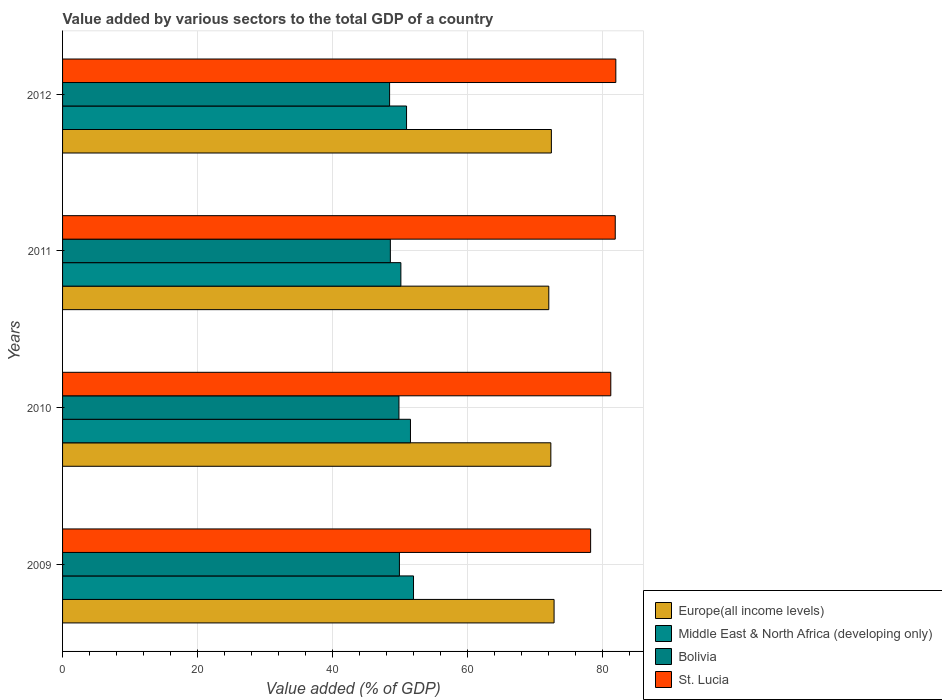How many different coloured bars are there?
Keep it short and to the point. 4. How many groups of bars are there?
Provide a succinct answer. 4. Are the number of bars per tick equal to the number of legend labels?
Your response must be concise. Yes. What is the label of the 4th group of bars from the top?
Your answer should be compact. 2009. What is the value added by various sectors to the total GDP in Europe(all income levels) in 2011?
Provide a succinct answer. 72.07. Across all years, what is the maximum value added by various sectors to the total GDP in Bolivia?
Ensure brevity in your answer.  49.93. Across all years, what is the minimum value added by various sectors to the total GDP in Europe(all income levels)?
Offer a very short reply. 72.07. In which year was the value added by various sectors to the total GDP in Middle East & North Africa (developing only) minimum?
Your answer should be compact. 2011. What is the total value added by various sectors to the total GDP in Middle East & North Africa (developing only) in the graph?
Ensure brevity in your answer.  204.71. What is the difference between the value added by various sectors to the total GDP in Europe(all income levels) in 2010 and that in 2011?
Offer a terse response. 0.3. What is the difference between the value added by various sectors to the total GDP in Middle East & North Africa (developing only) in 2011 and the value added by various sectors to the total GDP in Bolivia in 2012?
Your answer should be very brief. 1.67. What is the average value added by various sectors to the total GDP in Bolivia per year?
Make the answer very short. 49.21. In the year 2010, what is the difference between the value added by various sectors to the total GDP in Bolivia and value added by various sectors to the total GDP in St. Lucia?
Ensure brevity in your answer.  -31.4. What is the ratio of the value added by various sectors to the total GDP in St. Lucia in 2009 to that in 2010?
Provide a succinct answer. 0.96. Is the value added by various sectors to the total GDP in Bolivia in 2011 less than that in 2012?
Your answer should be compact. No. Is the difference between the value added by various sectors to the total GDP in Bolivia in 2009 and 2011 greater than the difference between the value added by various sectors to the total GDP in St. Lucia in 2009 and 2011?
Provide a succinct answer. Yes. What is the difference between the highest and the second highest value added by various sectors to the total GDP in Europe(all income levels)?
Ensure brevity in your answer.  0.4. What is the difference between the highest and the lowest value added by various sectors to the total GDP in Middle East & North Africa (developing only)?
Offer a terse response. 1.88. Is the sum of the value added by various sectors to the total GDP in Europe(all income levels) in 2009 and 2012 greater than the maximum value added by various sectors to the total GDP in Bolivia across all years?
Make the answer very short. Yes. What does the 1st bar from the top in 2012 represents?
Give a very brief answer. St. Lucia. What does the 4th bar from the bottom in 2009 represents?
Your answer should be very brief. St. Lucia. Are all the bars in the graph horizontal?
Ensure brevity in your answer.  Yes. What is the difference between two consecutive major ticks on the X-axis?
Ensure brevity in your answer.  20. Are the values on the major ticks of X-axis written in scientific E-notation?
Provide a short and direct response. No. Does the graph contain grids?
Your answer should be compact. Yes. What is the title of the graph?
Ensure brevity in your answer.  Value added by various sectors to the total GDP of a country. What is the label or title of the X-axis?
Make the answer very short. Value added (% of GDP). What is the label or title of the Y-axis?
Offer a terse response. Years. What is the Value added (% of GDP) in Europe(all income levels) in 2009?
Make the answer very short. 72.85. What is the Value added (% of GDP) in Middle East & North Africa (developing only) in 2009?
Provide a succinct answer. 52.02. What is the Value added (% of GDP) in Bolivia in 2009?
Your answer should be very brief. 49.93. What is the Value added (% of GDP) of St. Lucia in 2009?
Provide a succinct answer. 78.27. What is the Value added (% of GDP) of Europe(all income levels) in 2010?
Provide a short and direct response. 72.37. What is the Value added (% of GDP) of Middle East & North Africa (developing only) in 2010?
Offer a very short reply. 51.56. What is the Value added (% of GDP) of Bolivia in 2010?
Offer a very short reply. 49.86. What is the Value added (% of GDP) in St. Lucia in 2010?
Make the answer very short. 81.26. What is the Value added (% of GDP) of Europe(all income levels) in 2011?
Your response must be concise. 72.07. What is the Value added (% of GDP) of Middle East & North Africa (developing only) in 2011?
Keep it short and to the point. 50.14. What is the Value added (% of GDP) in Bolivia in 2011?
Make the answer very short. 48.58. What is the Value added (% of GDP) of St. Lucia in 2011?
Provide a short and direct response. 81.91. What is the Value added (% of GDP) of Europe(all income levels) in 2012?
Your response must be concise. 72.45. What is the Value added (% of GDP) of Middle East & North Africa (developing only) in 2012?
Offer a terse response. 50.98. What is the Value added (% of GDP) in Bolivia in 2012?
Your answer should be very brief. 48.47. What is the Value added (% of GDP) in St. Lucia in 2012?
Provide a short and direct response. 82. Across all years, what is the maximum Value added (% of GDP) in Europe(all income levels)?
Make the answer very short. 72.85. Across all years, what is the maximum Value added (% of GDP) in Middle East & North Africa (developing only)?
Give a very brief answer. 52.02. Across all years, what is the maximum Value added (% of GDP) of Bolivia?
Offer a very short reply. 49.93. Across all years, what is the maximum Value added (% of GDP) of St. Lucia?
Keep it short and to the point. 82. Across all years, what is the minimum Value added (% of GDP) of Europe(all income levels)?
Make the answer very short. 72.07. Across all years, what is the minimum Value added (% of GDP) in Middle East & North Africa (developing only)?
Your response must be concise. 50.14. Across all years, what is the minimum Value added (% of GDP) of Bolivia?
Your response must be concise. 48.47. Across all years, what is the minimum Value added (% of GDP) in St. Lucia?
Ensure brevity in your answer.  78.27. What is the total Value added (% of GDP) in Europe(all income levels) in the graph?
Offer a very short reply. 289.73. What is the total Value added (% of GDP) in Middle East & North Africa (developing only) in the graph?
Give a very brief answer. 204.71. What is the total Value added (% of GDP) of Bolivia in the graph?
Keep it short and to the point. 196.84. What is the total Value added (% of GDP) of St. Lucia in the graph?
Ensure brevity in your answer.  323.44. What is the difference between the Value added (% of GDP) of Europe(all income levels) in 2009 and that in 2010?
Keep it short and to the point. 0.48. What is the difference between the Value added (% of GDP) of Middle East & North Africa (developing only) in 2009 and that in 2010?
Provide a short and direct response. 0.45. What is the difference between the Value added (% of GDP) in Bolivia in 2009 and that in 2010?
Your answer should be compact. 0.07. What is the difference between the Value added (% of GDP) of St. Lucia in 2009 and that in 2010?
Your answer should be very brief. -2.99. What is the difference between the Value added (% of GDP) in Europe(all income levels) in 2009 and that in 2011?
Ensure brevity in your answer.  0.78. What is the difference between the Value added (% of GDP) of Middle East & North Africa (developing only) in 2009 and that in 2011?
Your response must be concise. 1.88. What is the difference between the Value added (% of GDP) of Bolivia in 2009 and that in 2011?
Make the answer very short. 1.34. What is the difference between the Value added (% of GDP) of St. Lucia in 2009 and that in 2011?
Provide a short and direct response. -3.65. What is the difference between the Value added (% of GDP) in Europe(all income levels) in 2009 and that in 2012?
Make the answer very short. 0.4. What is the difference between the Value added (% of GDP) of Middle East & North Africa (developing only) in 2009 and that in 2012?
Your answer should be compact. 1.03. What is the difference between the Value added (% of GDP) in Bolivia in 2009 and that in 2012?
Provide a short and direct response. 1.46. What is the difference between the Value added (% of GDP) in St. Lucia in 2009 and that in 2012?
Give a very brief answer. -3.73. What is the difference between the Value added (% of GDP) in Europe(all income levels) in 2010 and that in 2011?
Your answer should be very brief. 0.3. What is the difference between the Value added (% of GDP) of Middle East & North Africa (developing only) in 2010 and that in 2011?
Offer a very short reply. 1.42. What is the difference between the Value added (% of GDP) of Bolivia in 2010 and that in 2011?
Keep it short and to the point. 1.27. What is the difference between the Value added (% of GDP) in St. Lucia in 2010 and that in 2011?
Your answer should be compact. -0.66. What is the difference between the Value added (% of GDP) of Europe(all income levels) in 2010 and that in 2012?
Provide a succinct answer. -0.08. What is the difference between the Value added (% of GDP) in Middle East & North Africa (developing only) in 2010 and that in 2012?
Your answer should be compact. 0.58. What is the difference between the Value added (% of GDP) of Bolivia in 2010 and that in 2012?
Keep it short and to the point. 1.39. What is the difference between the Value added (% of GDP) in St. Lucia in 2010 and that in 2012?
Offer a very short reply. -0.74. What is the difference between the Value added (% of GDP) in Europe(all income levels) in 2011 and that in 2012?
Provide a succinct answer. -0.38. What is the difference between the Value added (% of GDP) in Middle East & North Africa (developing only) in 2011 and that in 2012?
Make the answer very short. -0.84. What is the difference between the Value added (% of GDP) of Bolivia in 2011 and that in 2012?
Your answer should be very brief. 0.11. What is the difference between the Value added (% of GDP) in St. Lucia in 2011 and that in 2012?
Make the answer very short. -0.09. What is the difference between the Value added (% of GDP) of Europe(all income levels) in 2009 and the Value added (% of GDP) of Middle East & North Africa (developing only) in 2010?
Your answer should be very brief. 21.28. What is the difference between the Value added (% of GDP) in Europe(all income levels) in 2009 and the Value added (% of GDP) in Bolivia in 2010?
Offer a very short reply. 22.99. What is the difference between the Value added (% of GDP) of Europe(all income levels) in 2009 and the Value added (% of GDP) of St. Lucia in 2010?
Keep it short and to the point. -8.41. What is the difference between the Value added (% of GDP) in Middle East & North Africa (developing only) in 2009 and the Value added (% of GDP) in Bolivia in 2010?
Provide a short and direct response. 2.16. What is the difference between the Value added (% of GDP) in Middle East & North Africa (developing only) in 2009 and the Value added (% of GDP) in St. Lucia in 2010?
Your response must be concise. -29.24. What is the difference between the Value added (% of GDP) of Bolivia in 2009 and the Value added (% of GDP) of St. Lucia in 2010?
Provide a succinct answer. -31.33. What is the difference between the Value added (% of GDP) in Europe(all income levels) in 2009 and the Value added (% of GDP) in Middle East & North Africa (developing only) in 2011?
Your answer should be very brief. 22.71. What is the difference between the Value added (% of GDP) in Europe(all income levels) in 2009 and the Value added (% of GDP) in Bolivia in 2011?
Your answer should be compact. 24.26. What is the difference between the Value added (% of GDP) in Europe(all income levels) in 2009 and the Value added (% of GDP) in St. Lucia in 2011?
Your answer should be very brief. -9.07. What is the difference between the Value added (% of GDP) of Middle East & North Africa (developing only) in 2009 and the Value added (% of GDP) of Bolivia in 2011?
Offer a very short reply. 3.43. What is the difference between the Value added (% of GDP) of Middle East & North Africa (developing only) in 2009 and the Value added (% of GDP) of St. Lucia in 2011?
Provide a short and direct response. -29.9. What is the difference between the Value added (% of GDP) in Bolivia in 2009 and the Value added (% of GDP) in St. Lucia in 2011?
Ensure brevity in your answer.  -31.99. What is the difference between the Value added (% of GDP) of Europe(all income levels) in 2009 and the Value added (% of GDP) of Middle East & North Africa (developing only) in 2012?
Provide a succinct answer. 21.87. What is the difference between the Value added (% of GDP) of Europe(all income levels) in 2009 and the Value added (% of GDP) of Bolivia in 2012?
Your answer should be compact. 24.38. What is the difference between the Value added (% of GDP) in Europe(all income levels) in 2009 and the Value added (% of GDP) in St. Lucia in 2012?
Ensure brevity in your answer.  -9.15. What is the difference between the Value added (% of GDP) of Middle East & North Africa (developing only) in 2009 and the Value added (% of GDP) of Bolivia in 2012?
Offer a terse response. 3.55. What is the difference between the Value added (% of GDP) in Middle East & North Africa (developing only) in 2009 and the Value added (% of GDP) in St. Lucia in 2012?
Keep it short and to the point. -29.99. What is the difference between the Value added (% of GDP) in Bolivia in 2009 and the Value added (% of GDP) in St. Lucia in 2012?
Ensure brevity in your answer.  -32.08. What is the difference between the Value added (% of GDP) of Europe(all income levels) in 2010 and the Value added (% of GDP) of Middle East & North Africa (developing only) in 2011?
Ensure brevity in your answer.  22.23. What is the difference between the Value added (% of GDP) in Europe(all income levels) in 2010 and the Value added (% of GDP) in Bolivia in 2011?
Provide a short and direct response. 23.79. What is the difference between the Value added (% of GDP) of Europe(all income levels) in 2010 and the Value added (% of GDP) of St. Lucia in 2011?
Provide a short and direct response. -9.54. What is the difference between the Value added (% of GDP) in Middle East & North Africa (developing only) in 2010 and the Value added (% of GDP) in Bolivia in 2011?
Make the answer very short. 2.98. What is the difference between the Value added (% of GDP) of Middle East & North Africa (developing only) in 2010 and the Value added (% of GDP) of St. Lucia in 2011?
Your answer should be very brief. -30.35. What is the difference between the Value added (% of GDP) in Bolivia in 2010 and the Value added (% of GDP) in St. Lucia in 2011?
Give a very brief answer. -32.06. What is the difference between the Value added (% of GDP) in Europe(all income levels) in 2010 and the Value added (% of GDP) in Middle East & North Africa (developing only) in 2012?
Provide a succinct answer. 21.39. What is the difference between the Value added (% of GDP) of Europe(all income levels) in 2010 and the Value added (% of GDP) of Bolivia in 2012?
Your answer should be very brief. 23.9. What is the difference between the Value added (% of GDP) of Europe(all income levels) in 2010 and the Value added (% of GDP) of St. Lucia in 2012?
Give a very brief answer. -9.63. What is the difference between the Value added (% of GDP) in Middle East & North Africa (developing only) in 2010 and the Value added (% of GDP) in Bolivia in 2012?
Offer a very short reply. 3.09. What is the difference between the Value added (% of GDP) in Middle East & North Africa (developing only) in 2010 and the Value added (% of GDP) in St. Lucia in 2012?
Ensure brevity in your answer.  -30.44. What is the difference between the Value added (% of GDP) of Bolivia in 2010 and the Value added (% of GDP) of St. Lucia in 2012?
Provide a succinct answer. -32.15. What is the difference between the Value added (% of GDP) in Europe(all income levels) in 2011 and the Value added (% of GDP) in Middle East & North Africa (developing only) in 2012?
Provide a short and direct response. 21.08. What is the difference between the Value added (% of GDP) in Europe(all income levels) in 2011 and the Value added (% of GDP) in Bolivia in 2012?
Keep it short and to the point. 23.6. What is the difference between the Value added (% of GDP) in Europe(all income levels) in 2011 and the Value added (% of GDP) in St. Lucia in 2012?
Ensure brevity in your answer.  -9.93. What is the difference between the Value added (% of GDP) in Middle East & North Africa (developing only) in 2011 and the Value added (% of GDP) in Bolivia in 2012?
Give a very brief answer. 1.67. What is the difference between the Value added (% of GDP) of Middle East & North Africa (developing only) in 2011 and the Value added (% of GDP) of St. Lucia in 2012?
Give a very brief answer. -31.86. What is the difference between the Value added (% of GDP) of Bolivia in 2011 and the Value added (% of GDP) of St. Lucia in 2012?
Offer a very short reply. -33.42. What is the average Value added (% of GDP) in Europe(all income levels) per year?
Ensure brevity in your answer.  72.43. What is the average Value added (% of GDP) in Middle East & North Africa (developing only) per year?
Offer a terse response. 51.18. What is the average Value added (% of GDP) in Bolivia per year?
Offer a terse response. 49.21. What is the average Value added (% of GDP) in St. Lucia per year?
Your answer should be compact. 80.86. In the year 2009, what is the difference between the Value added (% of GDP) of Europe(all income levels) and Value added (% of GDP) of Middle East & North Africa (developing only)?
Provide a short and direct response. 20.83. In the year 2009, what is the difference between the Value added (% of GDP) of Europe(all income levels) and Value added (% of GDP) of Bolivia?
Give a very brief answer. 22.92. In the year 2009, what is the difference between the Value added (% of GDP) in Europe(all income levels) and Value added (% of GDP) in St. Lucia?
Make the answer very short. -5.42. In the year 2009, what is the difference between the Value added (% of GDP) of Middle East & North Africa (developing only) and Value added (% of GDP) of Bolivia?
Your answer should be compact. 2.09. In the year 2009, what is the difference between the Value added (% of GDP) of Middle East & North Africa (developing only) and Value added (% of GDP) of St. Lucia?
Offer a terse response. -26.25. In the year 2009, what is the difference between the Value added (% of GDP) of Bolivia and Value added (% of GDP) of St. Lucia?
Make the answer very short. -28.34. In the year 2010, what is the difference between the Value added (% of GDP) in Europe(all income levels) and Value added (% of GDP) in Middle East & North Africa (developing only)?
Provide a succinct answer. 20.81. In the year 2010, what is the difference between the Value added (% of GDP) in Europe(all income levels) and Value added (% of GDP) in Bolivia?
Keep it short and to the point. 22.51. In the year 2010, what is the difference between the Value added (% of GDP) of Europe(all income levels) and Value added (% of GDP) of St. Lucia?
Offer a terse response. -8.89. In the year 2010, what is the difference between the Value added (% of GDP) in Middle East & North Africa (developing only) and Value added (% of GDP) in Bolivia?
Provide a succinct answer. 1.71. In the year 2010, what is the difference between the Value added (% of GDP) of Middle East & North Africa (developing only) and Value added (% of GDP) of St. Lucia?
Your answer should be very brief. -29.69. In the year 2010, what is the difference between the Value added (% of GDP) of Bolivia and Value added (% of GDP) of St. Lucia?
Your answer should be compact. -31.4. In the year 2011, what is the difference between the Value added (% of GDP) in Europe(all income levels) and Value added (% of GDP) in Middle East & North Africa (developing only)?
Give a very brief answer. 21.93. In the year 2011, what is the difference between the Value added (% of GDP) in Europe(all income levels) and Value added (% of GDP) in Bolivia?
Keep it short and to the point. 23.48. In the year 2011, what is the difference between the Value added (% of GDP) of Europe(all income levels) and Value added (% of GDP) of St. Lucia?
Provide a short and direct response. -9.85. In the year 2011, what is the difference between the Value added (% of GDP) in Middle East & North Africa (developing only) and Value added (% of GDP) in Bolivia?
Your answer should be compact. 1.56. In the year 2011, what is the difference between the Value added (% of GDP) of Middle East & North Africa (developing only) and Value added (% of GDP) of St. Lucia?
Provide a succinct answer. -31.77. In the year 2011, what is the difference between the Value added (% of GDP) of Bolivia and Value added (% of GDP) of St. Lucia?
Give a very brief answer. -33.33. In the year 2012, what is the difference between the Value added (% of GDP) in Europe(all income levels) and Value added (% of GDP) in Middle East & North Africa (developing only)?
Make the answer very short. 21.47. In the year 2012, what is the difference between the Value added (% of GDP) in Europe(all income levels) and Value added (% of GDP) in Bolivia?
Ensure brevity in your answer.  23.98. In the year 2012, what is the difference between the Value added (% of GDP) in Europe(all income levels) and Value added (% of GDP) in St. Lucia?
Your response must be concise. -9.55. In the year 2012, what is the difference between the Value added (% of GDP) of Middle East & North Africa (developing only) and Value added (% of GDP) of Bolivia?
Ensure brevity in your answer.  2.51. In the year 2012, what is the difference between the Value added (% of GDP) of Middle East & North Africa (developing only) and Value added (% of GDP) of St. Lucia?
Offer a very short reply. -31.02. In the year 2012, what is the difference between the Value added (% of GDP) of Bolivia and Value added (% of GDP) of St. Lucia?
Keep it short and to the point. -33.53. What is the ratio of the Value added (% of GDP) of Europe(all income levels) in 2009 to that in 2010?
Offer a very short reply. 1.01. What is the ratio of the Value added (% of GDP) in Middle East & North Africa (developing only) in 2009 to that in 2010?
Provide a succinct answer. 1.01. What is the ratio of the Value added (% of GDP) in Bolivia in 2009 to that in 2010?
Offer a very short reply. 1. What is the ratio of the Value added (% of GDP) in St. Lucia in 2009 to that in 2010?
Ensure brevity in your answer.  0.96. What is the ratio of the Value added (% of GDP) of Europe(all income levels) in 2009 to that in 2011?
Your answer should be very brief. 1.01. What is the ratio of the Value added (% of GDP) of Middle East & North Africa (developing only) in 2009 to that in 2011?
Keep it short and to the point. 1.04. What is the ratio of the Value added (% of GDP) of Bolivia in 2009 to that in 2011?
Keep it short and to the point. 1.03. What is the ratio of the Value added (% of GDP) in St. Lucia in 2009 to that in 2011?
Your response must be concise. 0.96. What is the ratio of the Value added (% of GDP) of Middle East & North Africa (developing only) in 2009 to that in 2012?
Your response must be concise. 1.02. What is the ratio of the Value added (% of GDP) in St. Lucia in 2009 to that in 2012?
Give a very brief answer. 0.95. What is the ratio of the Value added (% of GDP) of Middle East & North Africa (developing only) in 2010 to that in 2011?
Provide a short and direct response. 1.03. What is the ratio of the Value added (% of GDP) of Bolivia in 2010 to that in 2011?
Your answer should be compact. 1.03. What is the ratio of the Value added (% of GDP) of Europe(all income levels) in 2010 to that in 2012?
Ensure brevity in your answer.  1. What is the ratio of the Value added (% of GDP) of Middle East & North Africa (developing only) in 2010 to that in 2012?
Offer a terse response. 1.01. What is the ratio of the Value added (% of GDP) in Bolivia in 2010 to that in 2012?
Your answer should be very brief. 1.03. What is the ratio of the Value added (% of GDP) of St. Lucia in 2010 to that in 2012?
Offer a very short reply. 0.99. What is the ratio of the Value added (% of GDP) in Middle East & North Africa (developing only) in 2011 to that in 2012?
Offer a very short reply. 0.98. What is the ratio of the Value added (% of GDP) of St. Lucia in 2011 to that in 2012?
Offer a very short reply. 1. What is the difference between the highest and the second highest Value added (% of GDP) of Europe(all income levels)?
Offer a terse response. 0.4. What is the difference between the highest and the second highest Value added (% of GDP) of Middle East & North Africa (developing only)?
Your response must be concise. 0.45. What is the difference between the highest and the second highest Value added (% of GDP) of Bolivia?
Provide a succinct answer. 0.07. What is the difference between the highest and the second highest Value added (% of GDP) in St. Lucia?
Your answer should be compact. 0.09. What is the difference between the highest and the lowest Value added (% of GDP) in Europe(all income levels)?
Your response must be concise. 0.78. What is the difference between the highest and the lowest Value added (% of GDP) in Middle East & North Africa (developing only)?
Offer a terse response. 1.88. What is the difference between the highest and the lowest Value added (% of GDP) in Bolivia?
Provide a succinct answer. 1.46. What is the difference between the highest and the lowest Value added (% of GDP) of St. Lucia?
Offer a very short reply. 3.73. 